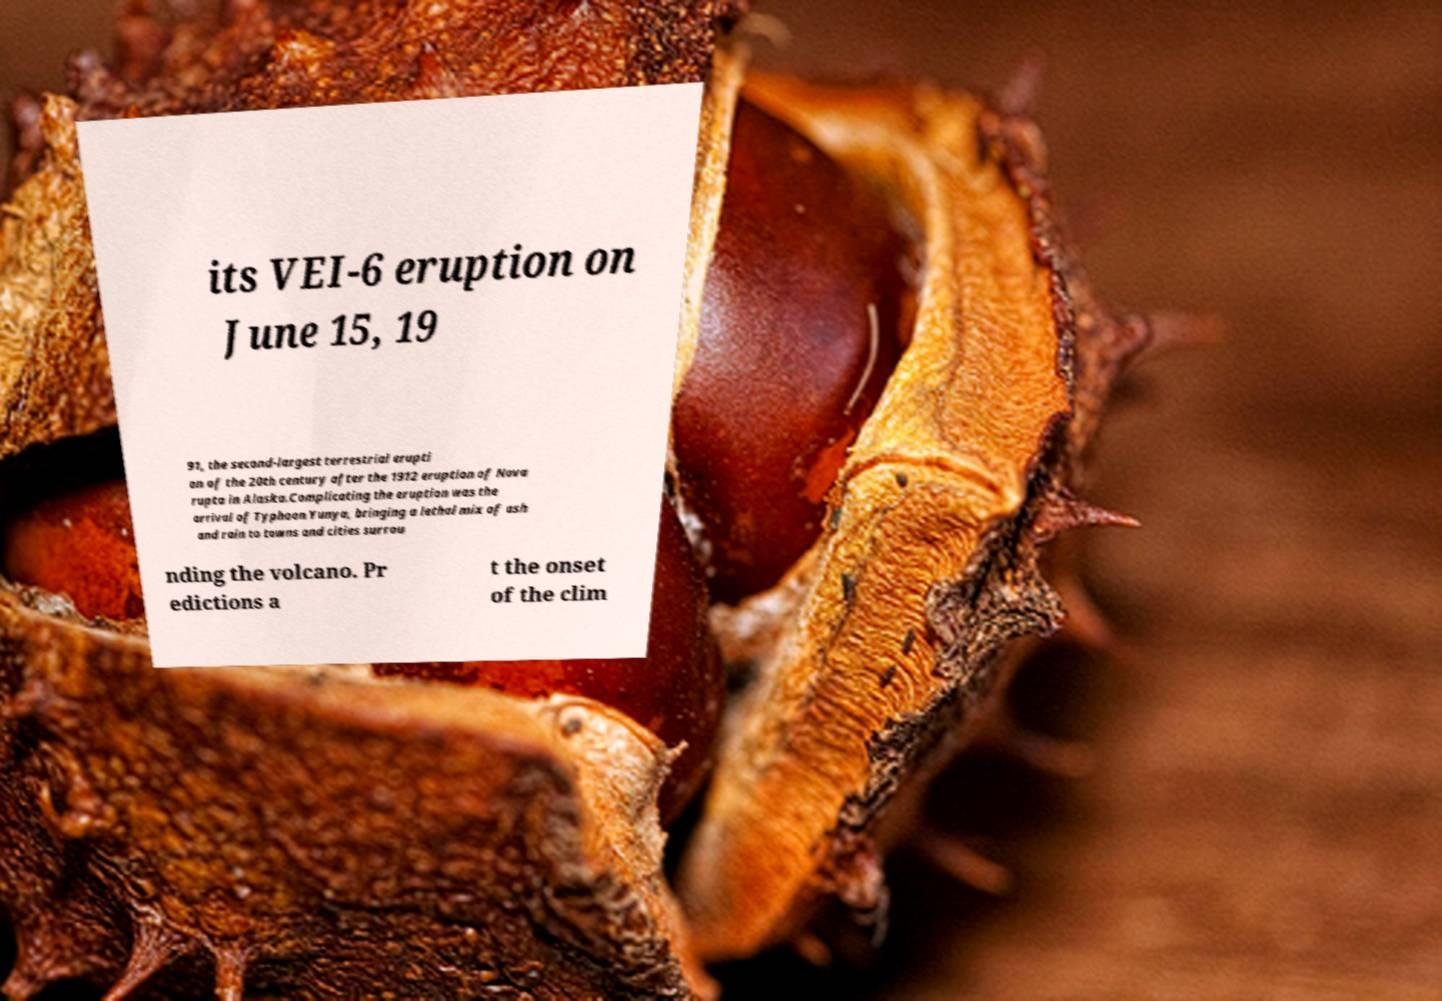What messages or text are displayed in this image? I need them in a readable, typed format. its VEI-6 eruption on June 15, 19 91, the second-largest terrestrial erupti on of the 20th century after the 1912 eruption of Nova rupta in Alaska.Complicating the eruption was the arrival of Typhoon Yunya, bringing a lethal mix of ash and rain to towns and cities surrou nding the volcano. Pr edictions a t the onset of the clim 